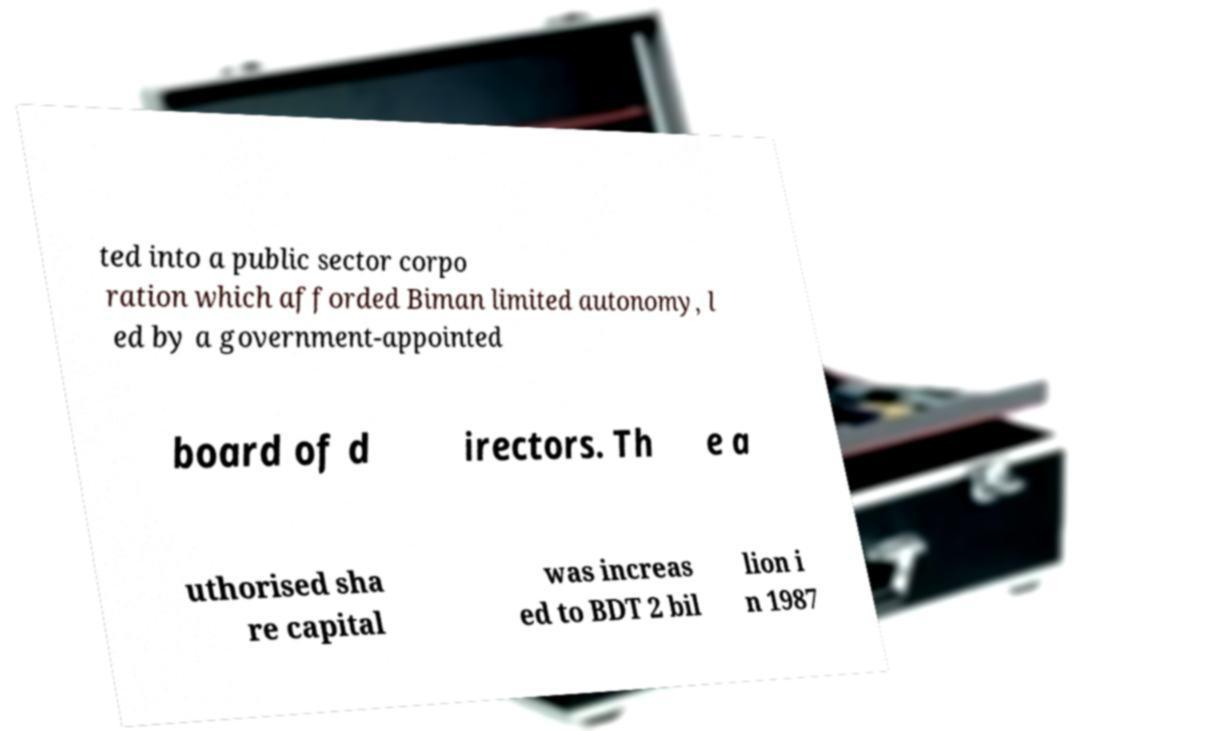I need the written content from this picture converted into text. Can you do that? ted into a public sector corpo ration which afforded Biman limited autonomy, l ed by a government-appointed board of d irectors. Th e a uthorised sha re capital was increas ed to BDT 2 bil lion i n 1987 